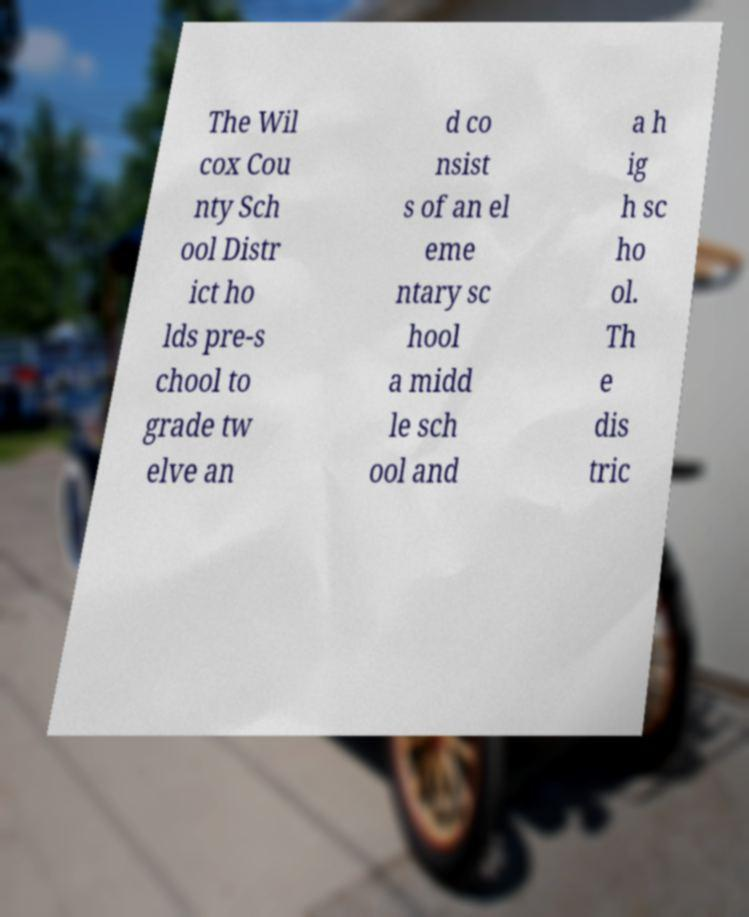I need the written content from this picture converted into text. Can you do that? The Wil cox Cou nty Sch ool Distr ict ho lds pre-s chool to grade tw elve an d co nsist s of an el eme ntary sc hool a midd le sch ool and a h ig h sc ho ol. Th e dis tric 